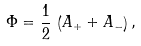Convert formula to latex. <formula><loc_0><loc_0><loc_500><loc_500>\Phi = \frac { 1 } { 2 } \, \left ( A _ { + } + A _ { - } \right ) ,</formula> 